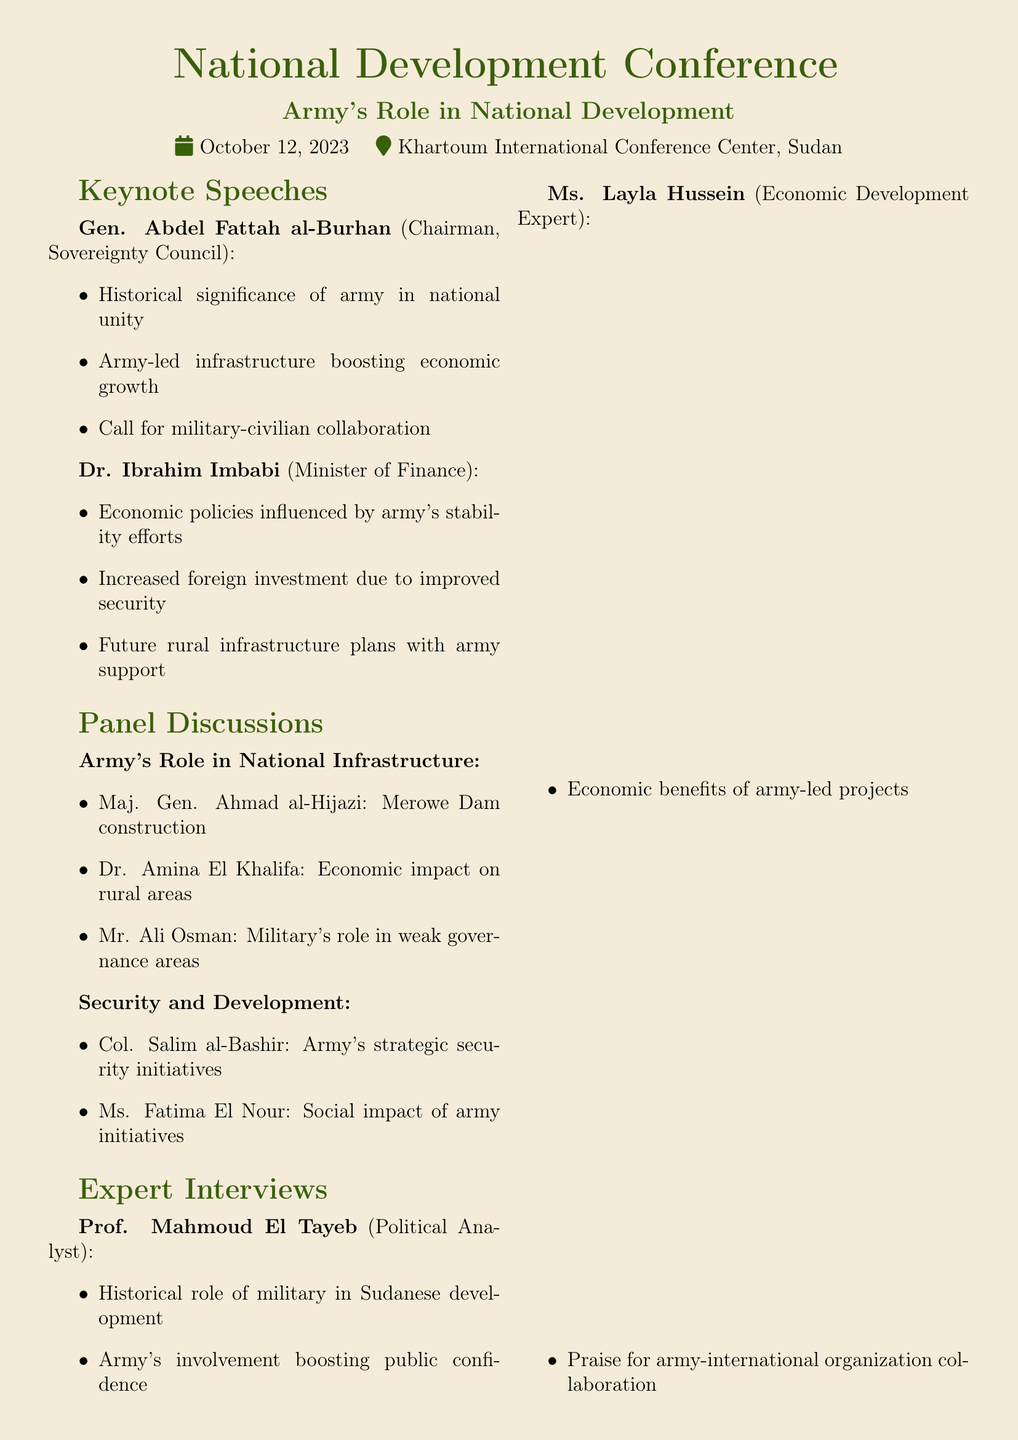What is the date of the National Development Conference? The date is specified in the document under the conference details section.
Answer: October 12, 2023 Who is the Chairman of the Sovereignty Council? The document lists individuals with their titles, specifically identifying the Chairman.
Answer: Gen. Abdel Fattah al-Burhan What is the role of the army according to Dr. Ibrahim Imbabi? The document details the economic policies influenced by various speakers, highlighting the army's contribution.
Answer: Stability efforts Which project is mentioned in Maj. Gen. Ahmad al-Hijazi's discussion? This refers to one of the panel discussions focusing on national infrastructure.
Answer: Merowe Dam construction What key takeaway emphasizes army-led initiatives? The key takeaways summarize the insights and implications discussed during the conference.
Answer: Positive socio-economic impact What is the focus of the panel discussion titled "Security and Development"? The document categorizes discussions, revealing their subjects.
Answer: Strategic security initiatives How does Prof. Mahmoud El Tayeb describe the military's historical role? The document provides a summary of expert opinions, addressing their views on the army's impact.
Answer: Boosting public confidence What type of cooperation is emphasized in the conference highlights? The highlights section reviews important themes that surfaced during the event.
Answer: Military-civilian cooperation What is the color theme used in the document? The document uses specific color codes that reflect its design and aesthetic appeal.
Answer: Army green 